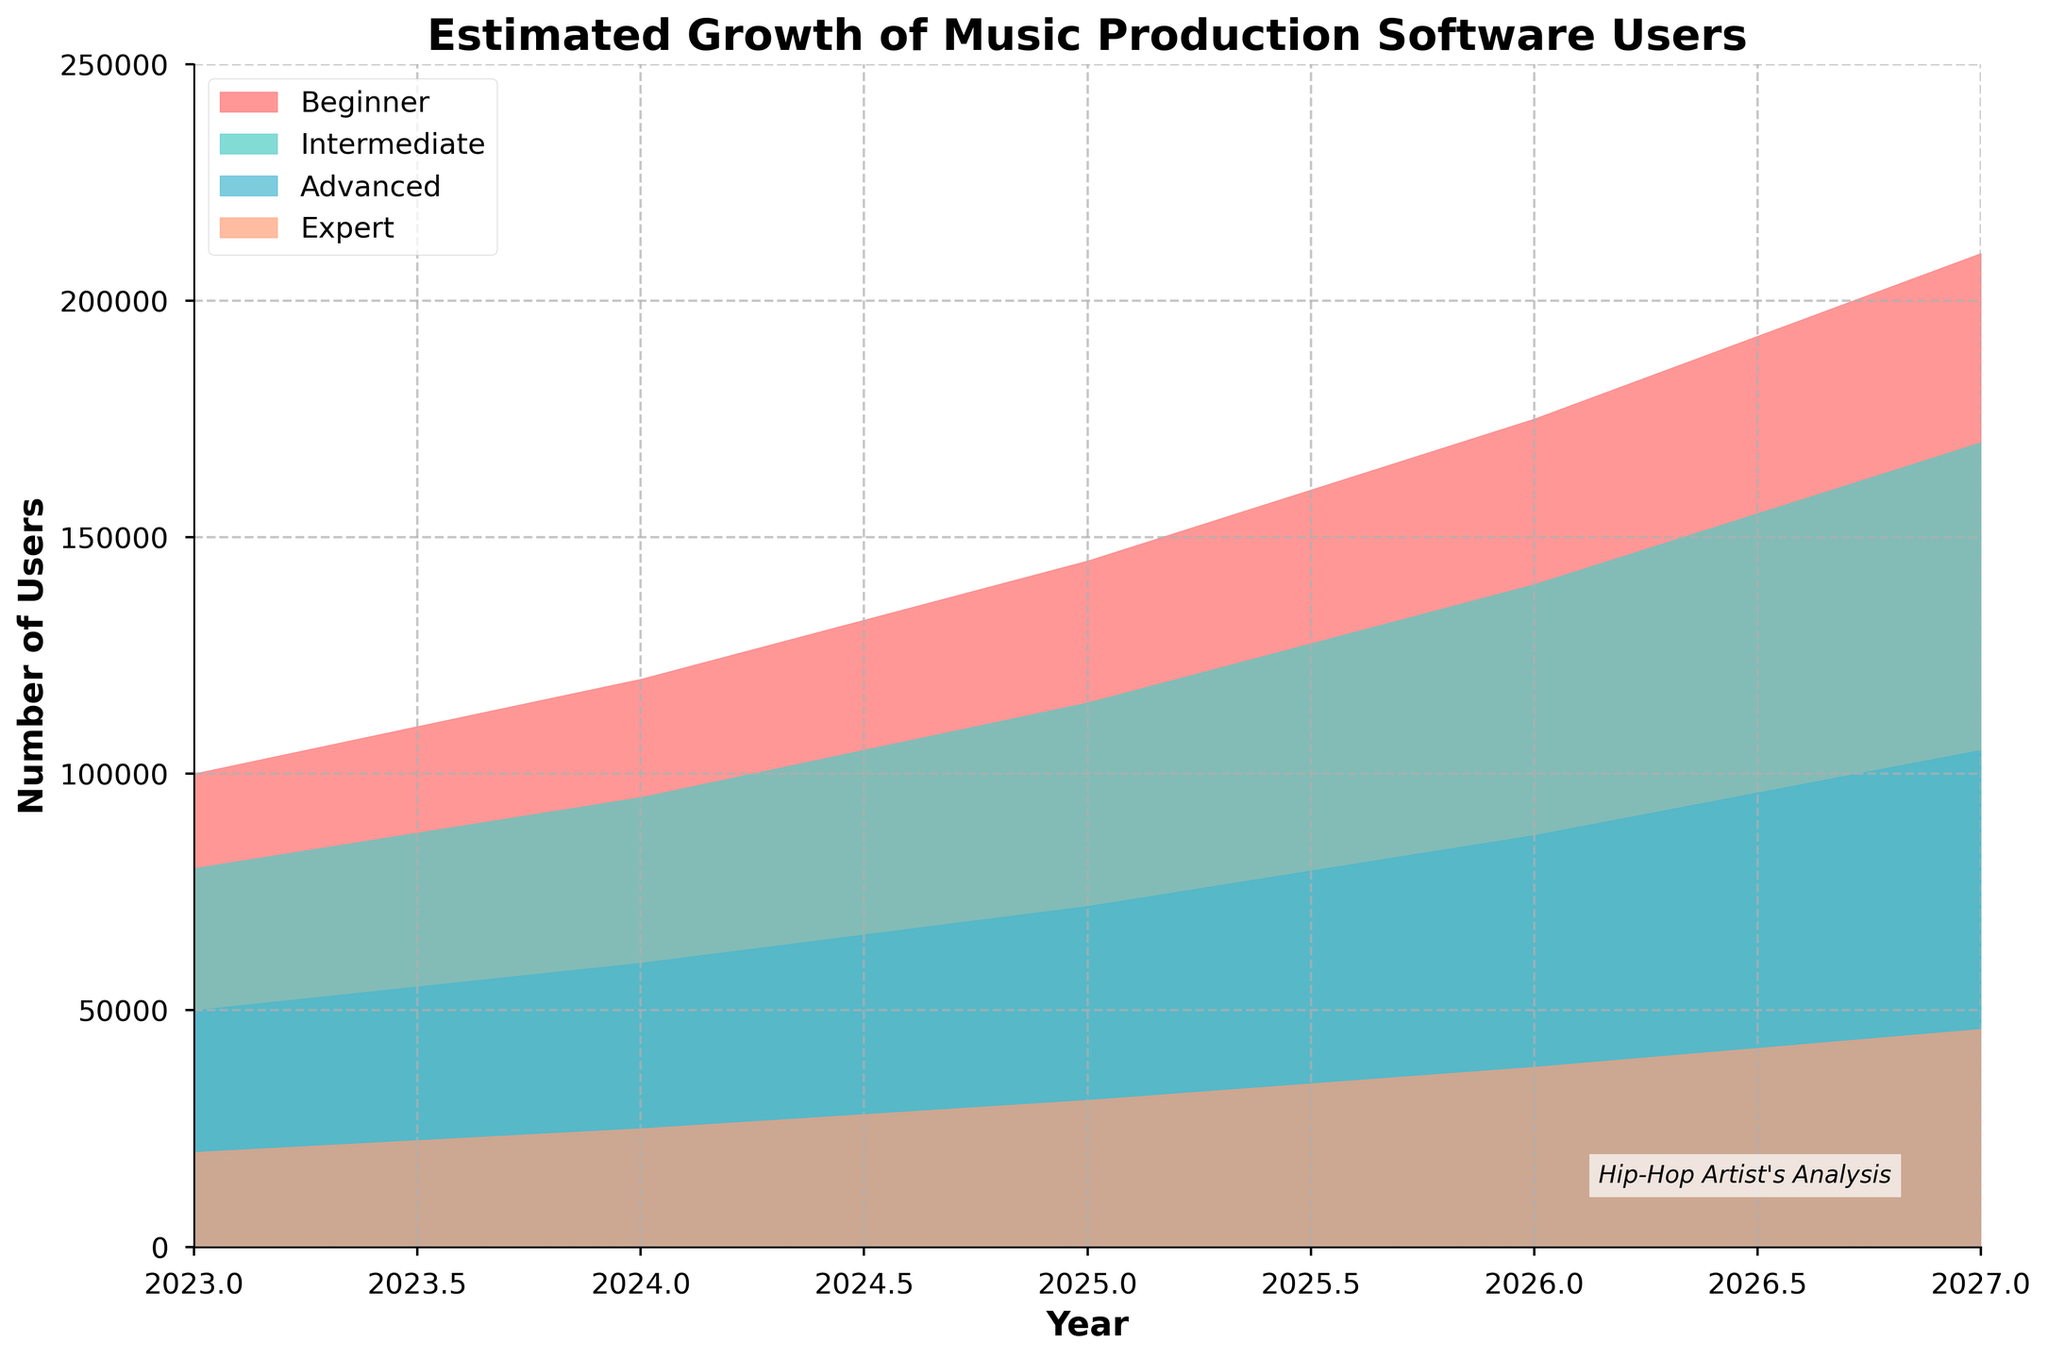What is the title of the chart? The title of the chart is located at the top and reads "Estimated Growth of Music Production Software Users."
Answer: Estimated Growth of Music Production Software Users Which user skill level shows the highest estimated growth in users from 2023 to 2027? By comparing the areas under each user's skill level categories over time, the "Beginner" group has the largest increase, going from 100,000 in 2023 to 210,000 in 2027.
Answer: Beginner How many categories of user skill levels are displayed in the chart? The legend on the chart shows four different colors, each representing a different skill category.
Answer: 4 What is the estimated number of intermediate users in 2025? We look at the bar for the year 2025 and refer to the segment colored for Intermediate users: It is 115,000.
Answer: 115,000 Which category of users sees the smallest growth from 2023 to 2027? Compare the start and end values for each category: "Expert" users grow from 20,000 in 2023 to 46,000 in 2027, which is the smallest increase among the categories.
Answer: Expert By how much do the number of advanced users increase between 2023 and 2026? Identify the values for Advanced users in 2023 and 2026, then subtract the former from the latter: 87,000 (2026) - 50,000 (2023) = 37,000.
Answer: 37,000 At which year do we see the biggest increase in the number of expert users, compared to the previous year? Calculate the differences for "Expert" users year-over-year and find the highest: 
  - 2024-2023 = 25,000 - 20,000 = 5,000
  - 2025-2024 = 31,000 - 25,000 = 6,000 (highest)
  - 2026-2025 = 38,000 - 31,000 = 7,000
  - 2027-2026 = 46,000 - 38,000 = 8,000
Answer: 2027 What is the total number of users projected for 2026 across all skill levels? Add the values of all user categories for the year 2026: 
  - 175,000 (Beginner) + 140,000 (Intermediate) + 87,000 (Advanced) + 38,000 (Expert) = 440,000
Answer: 440,000 Which user category consistently has a lower number of users than all others in each year shown? Compare the user numbers year-wise; "Expert" always has fewer users in comparison to other categories.
Answer: Expert 